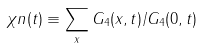<formula> <loc_0><loc_0><loc_500><loc_500>\chi n ( t ) \equiv \sum _ { x } G _ { 4 } ( x , t ) / G _ { 4 } ( 0 , t )</formula> 